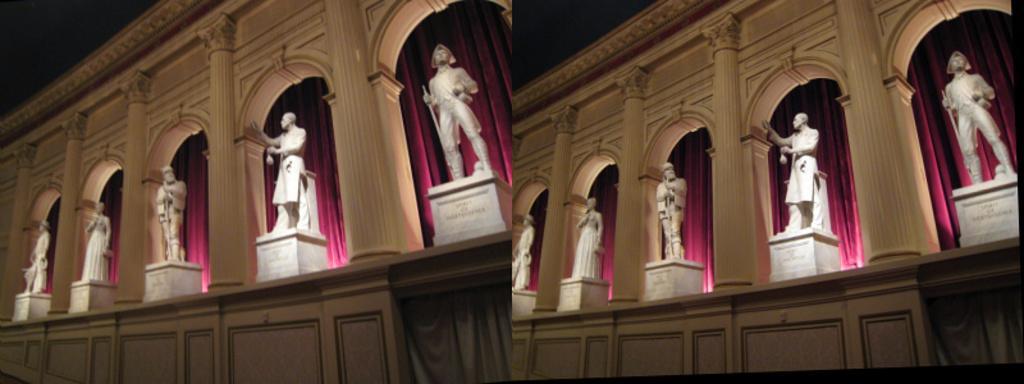In one or two sentences, can you explain what this image depicts? It is a collage picture. On the left side of the image, we can see one building, curtains, pillars with arches, statues and some text on the square shape structures. On the right side of the image, we can see the same image. 